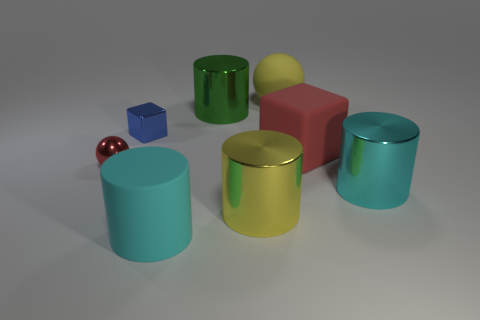What shapes can be seen in the image and can you count them? The image contains shapes of a cube, a sphere, a cuboid, and several cylinders. Specifically, there is one cube, one sphere, one cuboid, and four cylinders, making a total count of seven individual shapes. 